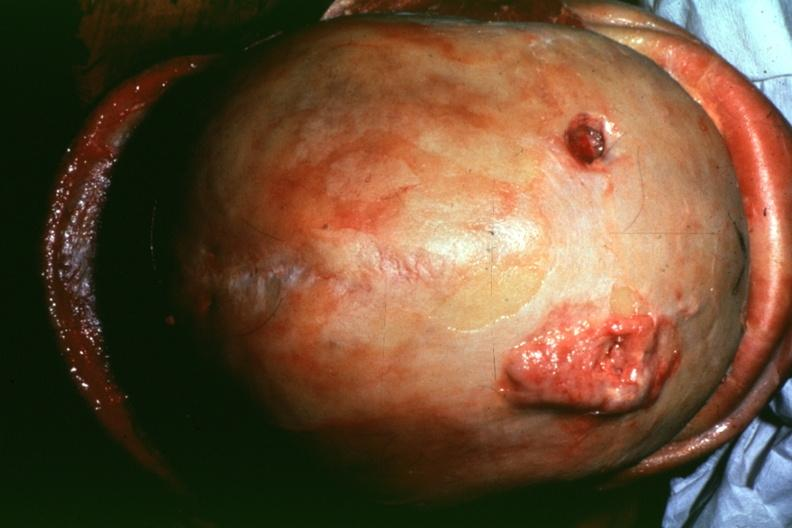does an opened peritoneal cavity cause by fibrous band strangulation show dr garcia tumors b4?
Answer the question using a single word or phrase. No 